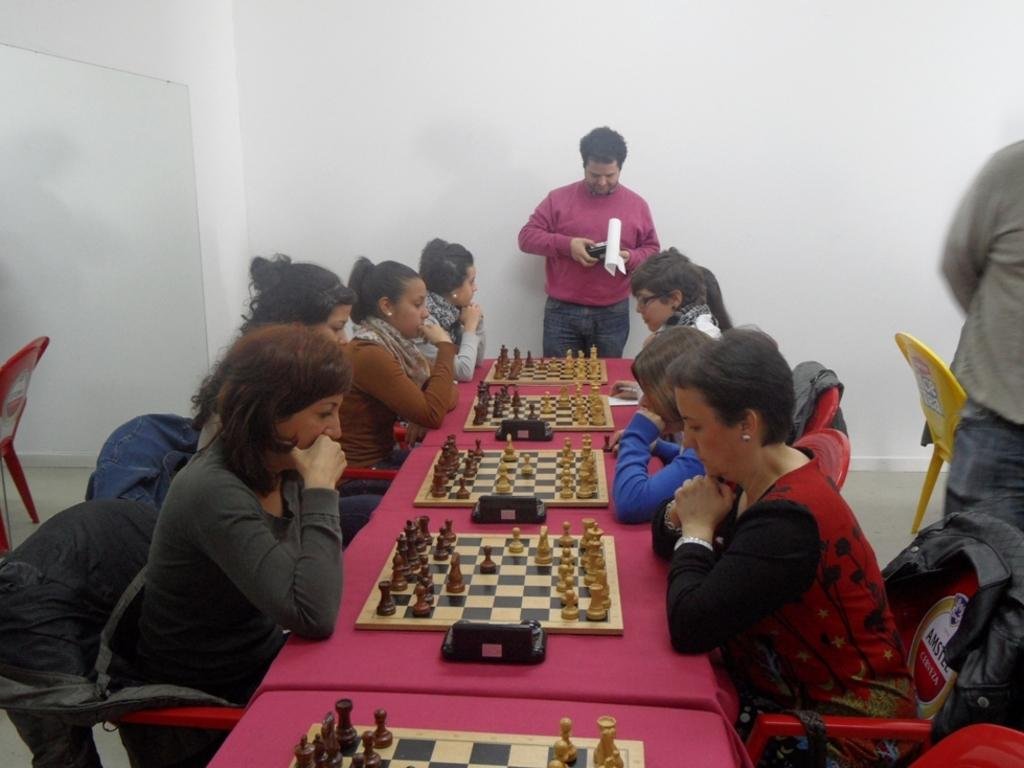What are the people in the image doing? The group of persons in the image are playing chess. Can you describe the activity taking place in the image? The people are playing chess, which is a strategic board game. Is there anyone else visible in the image besides the group of persons playing chess? Yes, there is a person standing in the background of the image. What type of impulse can be seen affecting the chess pieces in the image? There is no impulse affecting the chess pieces in the image; they are stationary on the board. What smell is associated with the chess game in the image? There is no smell associated with the chess game in the image, as it is a visual representation. 